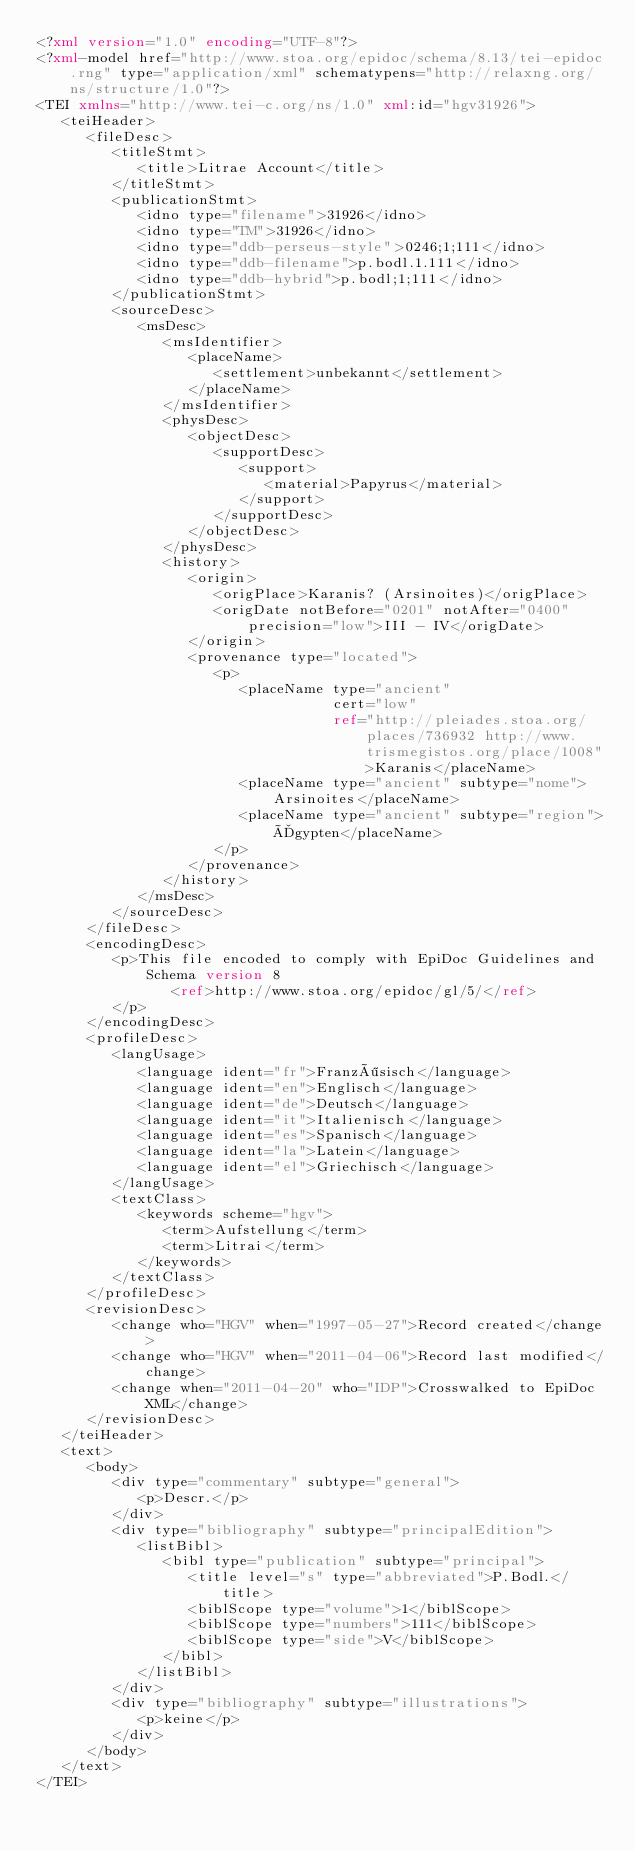Convert code to text. <code><loc_0><loc_0><loc_500><loc_500><_XML_><?xml version="1.0" encoding="UTF-8"?>
<?xml-model href="http://www.stoa.org/epidoc/schema/8.13/tei-epidoc.rng" type="application/xml" schematypens="http://relaxng.org/ns/structure/1.0"?>
<TEI xmlns="http://www.tei-c.org/ns/1.0" xml:id="hgv31926">
   <teiHeader>
      <fileDesc>
         <titleStmt>
            <title>Litrae Account</title>
         </titleStmt>
         <publicationStmt>
            <idno type="filename">31926</idno>
            <idno type="TM">31926</idno>
            <idno type="ddb-perseus-style">0246;1;111</idno>
            <idno type="ddb-filename">p.bodl.1.111</idno>
            <idno type="ddb-hybrid">p.bodl;1;111</idno>
         </publicationStmt>
         <sourceDesc>
            <msDesc>
               <msIdentifier>
                  <placeName>
                     <settlement>unbekannt</settlement>
                  </placeName>
               </msIdentifier>
               <physDesc>
                  <objectDesc>
                     <supportDesc>
                        <support>
                           <material>Papyrus</material>
                        </support>
                     </supportDesc>
                  </objectDesc>
               </physDesc>
               <history>
                  <origin>
                     <origPlace>Karanis? (Arsinoites)</origPlace>
                     <origDate notBefore="0201" notAfter="0400" precision="low">III - IV</origDate>
                  </origin>
                  <provenance type="located">
                     <p>
                        <placeName type="ancient"
                                   cert="low"
                                   ref="http://pleiades.stoa.org/places/736932 http://www.trismegistos.org/place/1008">Karanis</placeName>
                        <placeName type="ancient" subtype="nome">Arsinoites</placeName>
                        <placeName type="ancient" subtype="region">Ägypten</placeName>
                     </p>
                  </provenance>
               </history>
            </msDesc>
         </sourceDesc>
      </fileDesc>
      <encodingDesc>
         <p>This file encoded to comply with EpiDoc Guidelines and Schema version 8
                <ref>http://www.stoa.org/epidoc/gl/5/</ref>
         </p>
      </encodingDesc>
      <profileDesc>
         <langUsage>
            <language ident="fr">Französisch</language>
            <language ident="en">Englisch</language>
            <language ident="de">Deutsch</language>
            <language ident="it">Italienisch</language>
            <language ident="es">Spanisch</language>
            <language ident="la">Latein</language>
            <language ident="el">Griechisch</language>
         </langUsage>
         <textClass>
            <keywords scheme="hgv">
               <term>Aufstellung</term>
               <term>Litrai</term>
            </keywords>
         </textClass>
      </profileDesc>
      <revisionDesc>
         <change who="HGV" when="1997-05-27">Record created</change>
         <change who="HGV" when="2011-04-06">Record last modified</change>
         <change when="2011-04-20" who="IDP">Crosswalked to EpiDoc XML</change>
      </revisionDesc>
   </teiHeader>
   <text>
      <body>
         <div type="commentary" subtype="general">
            <p>Descr.</p>
         </div>
         <div type="bibliography" subtype="principalEdition">
            <listBibl>
               <bibl type="publication" subtype="principal">
                  <title level="s" type="abbreviated">P.Bodl.</title>
                  <biblScope type="volume">1</biblScope>
                  <biblScope type="numbers">111</biblScope>
                  <biblScope type="side">V</biblScope>
               </bibl>
            </listBibl>
         </div>
         <div type="bibliography" subtype="illustrations">
            <p>keine</p>
         </div>
      </body>
   </text>
</TEI>
</code> 